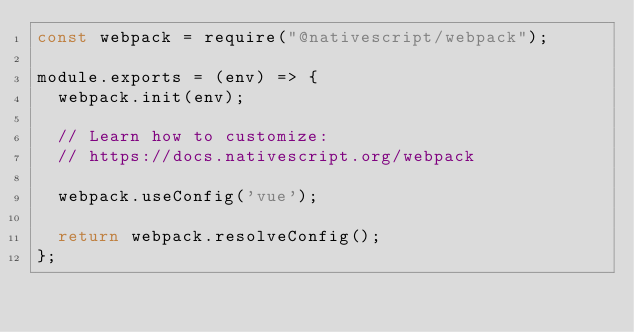Convert code to text. <code><loc_0><loc_0><loc_500><loc_500><_JavaScript_>const webpack = require("@nativescript/webpack");

module.exports = (env) => {
	webpack.init(env);

	// Learn how to customize:
	// https://docs.nativescript.org/webpack

	webpack.useConfig('vue');

	return webpack.resolveConfig();
};
</code> 